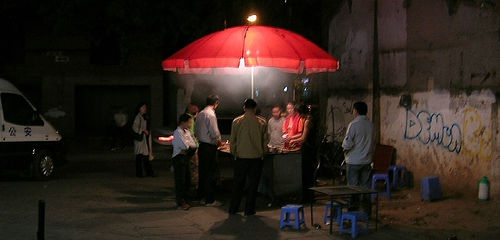Describe the objects in this image and their specific colors. I can see umbrella in black, salmon, red, brown, and maroon tones, car in black and gray tones, people in black, maroon, and brown tones, people in black, gray, and maroon tones, and people in black and gray tones in this image. 